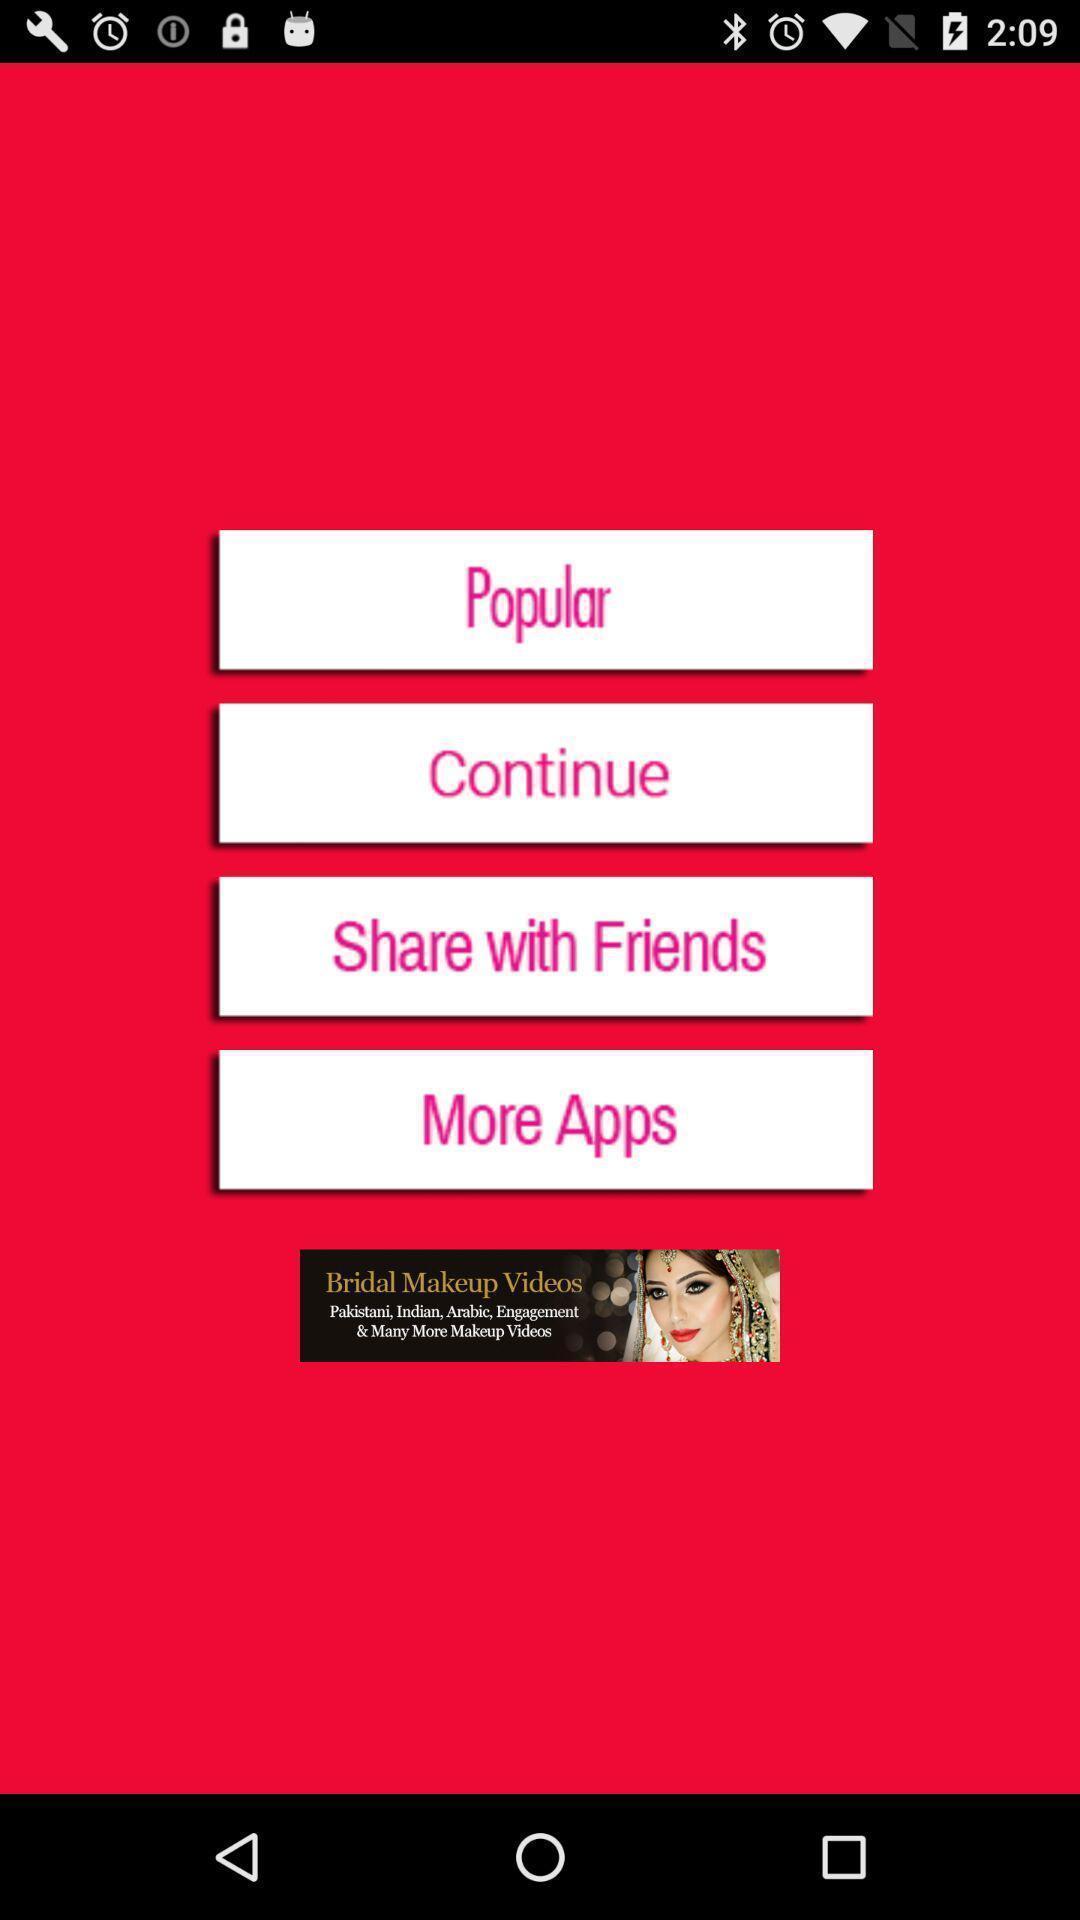Please provide a description for this image. Page with options. 